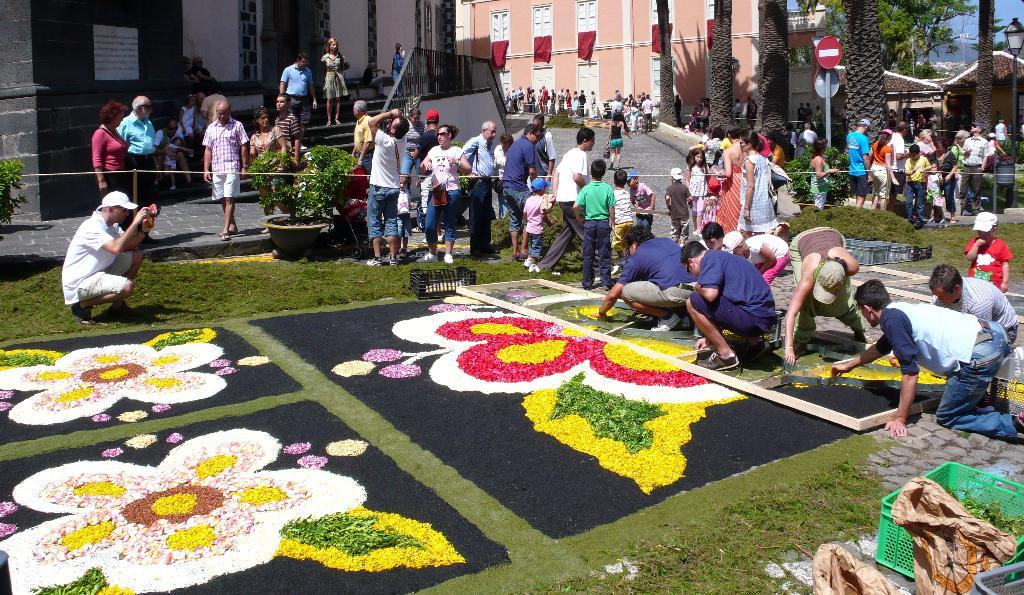What is on the floor in the image? There are flowers on the floor in the image. What can be seen in the middle of the image? People are visible in the middle of the image. What type of structures are present in the image? There are buildings in the image. What other natural elements can be seen in the image? Trees are present in the image. How many cakes are being shared between the partners in the image? There is no mention of cakes or partners in the image. What is the birth date of the person celebrating their birthday in the image? There is no indication of a birthday celebration in the image. 